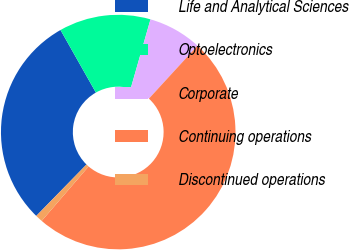Convert chart. <chart><loc_0><loc_0><loc_500><loc_500><pie_chart><fcel>Life and Analytical Sciences<fcel>Optoelectronics<fcel>Corporate<fcel>Continuing operations<fcel>Discontinued operations<nl><fcel>29.49%<fcel>12.63%<fcel>7.38%<fcel>49.5%<fcel>1.0%<nl></chart> 